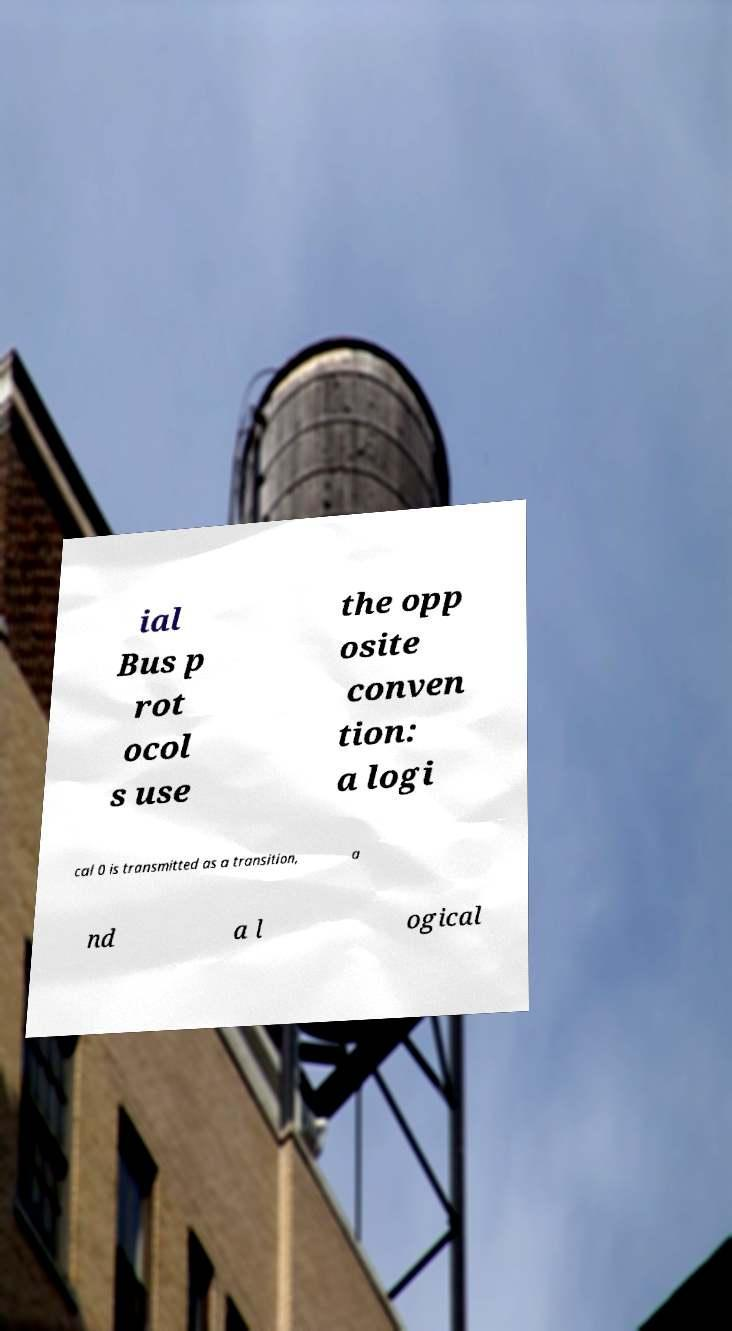Can you accurately transcribe the text from the provided image for me? ial Bus p rot ocol s use the opp osite conven tion: a logi cal 0 is transmitted as a transition, a nd a l ogical 